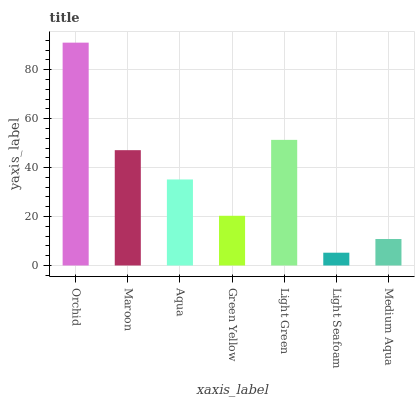Is Light Seafoam the minimum?
Answer yes or no. Yes. Is Orchid the maximum?
Answer yes or no. Yes. Is Maroon the minimum?
Answer yes or no. No. Is Maroon the maximum?
Answer yes or no. No. Is Orchid greater than Maroon?
Answer yes or no. Yes. Is Maroon less than Orchid?
Answer yes or no. Yes. Is Maroon greater than Orchid?
Answer yes or no. No. Is Orchid less than Maroon?
Answer yes or no. No. Is Aqua the high median?
Answer yes or no. Yes. Is Aqua the low median?
Answer yes or no. Yes. Is Medium Aqua the high median?
Answer yes or no. No. Is Light Green the low median?
Answer yes or no. No. 